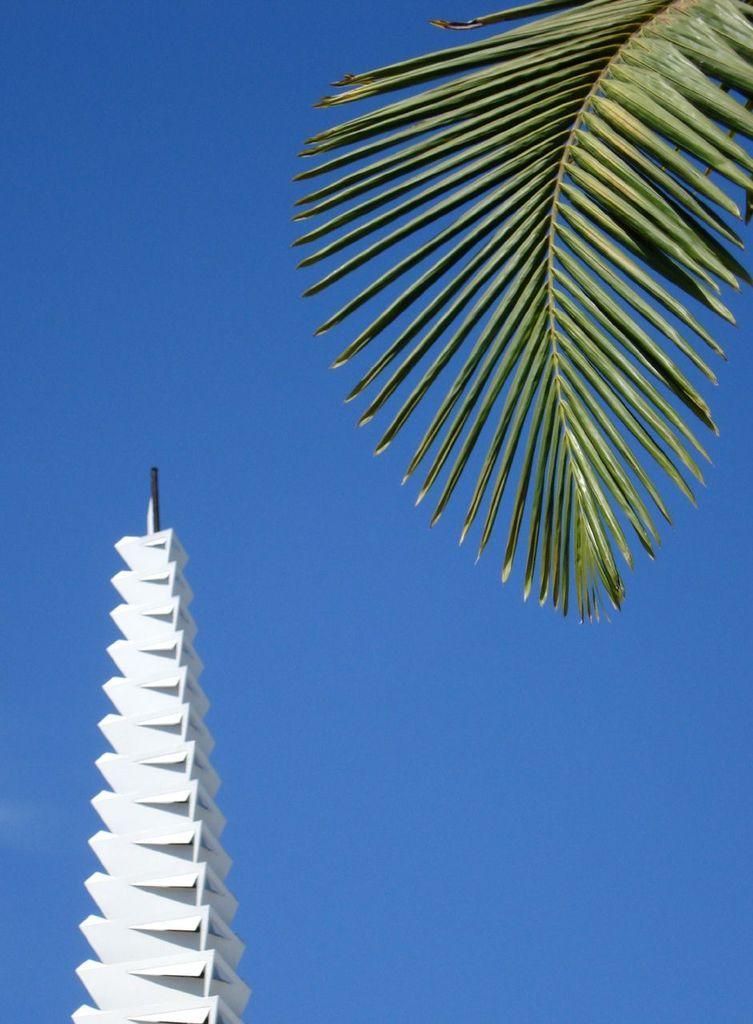Please provide a concise description of this image. In this image we can see a coconut tree leaf and tower. In the background there is a sky. 